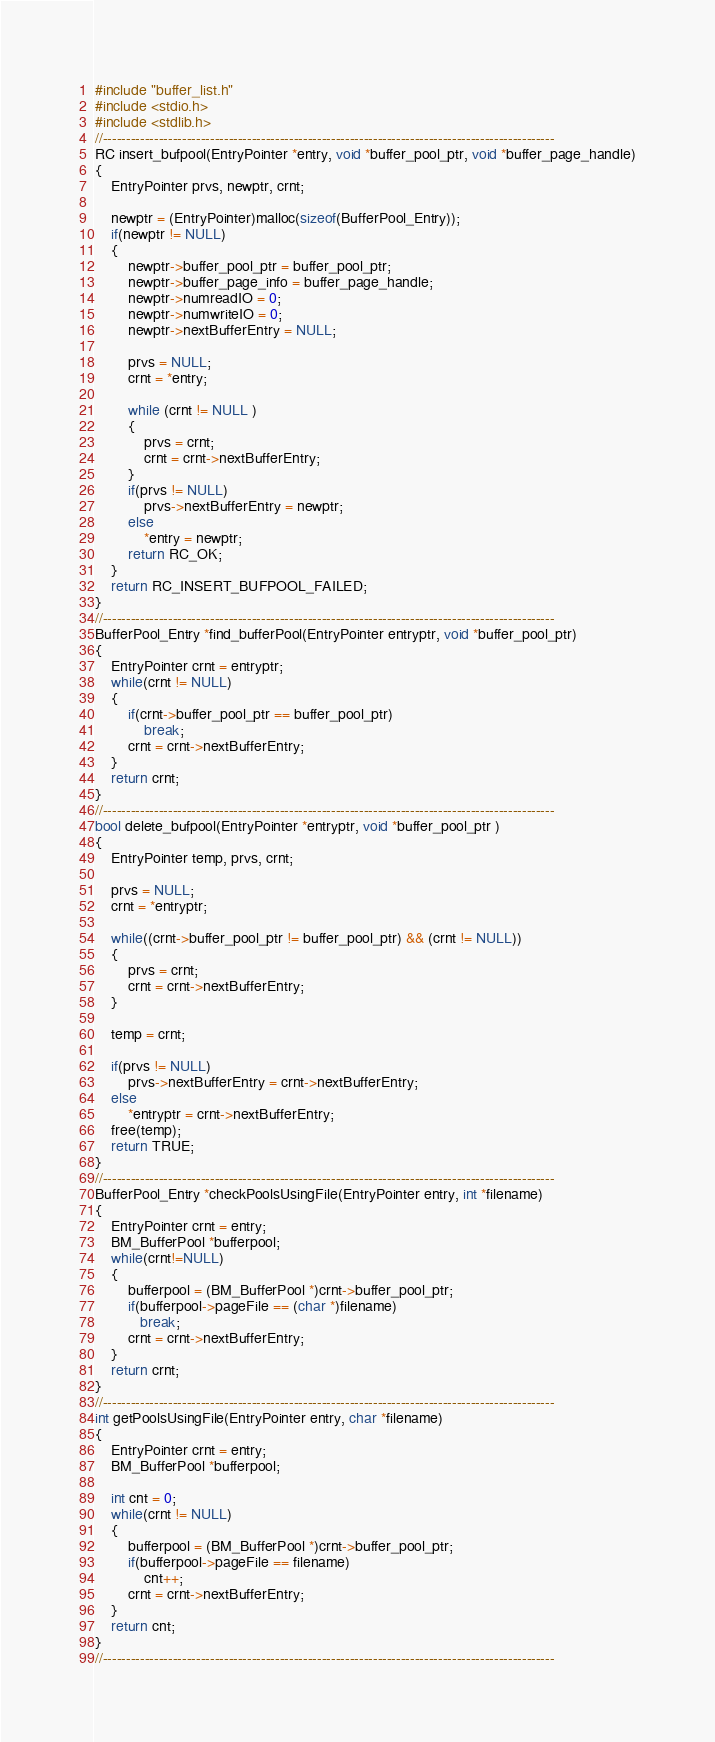Convert code to text. <code><loc_0><loc_0><loc_500><loc_500><_C_>#include "buffer_list.h"
#include <stdio.h>
#include <stdlib.h>
//-------------------------------------------------------------------------------------------------
RC insert_bufpool(EntryPointer *entry, void *buffer_pool_ptr, void *buffer_page_handle)
{    
    EntryPointer prvs, newptr, crnt;

    newptr = (EntryPointer)malloc(sizeof(BufferPool_Entry));
    if(newptr != NULL)
    {
        newptr->buffer_pool_ptr = buffer_pool_ptr;
        newptr->buffer_page_info = buffer_page_handle;
        newptr->numreadIO = 0;
        newptr->numwriteIO = 0;
        newptr->nextBufferEntry = NULL;

        prvs = NULL;
        crnt = *entry;

        while (crnt != NULL )
        {
            prvs = crnt;
            crnt = crnt->nextBufferEntry;
        }
        if(prvs != NULL)
            prvs->nextBufferEntry = newptr;
        else
            *entry = newptr;
        return RC_OK;
    }
    return RC_INSERT_BUFPOOL_FAILED;
}
//-------------------------------------------------------------------------------------------------
BufferPool_Entry *find_bufferPool(EntryPointer entryptr, void *buffer_pool_ptr)
{
    EntryPointer crnt = entryptr;
    while(crnt != NULL)
    {
        if(crnt->buffer_pool_ptr == buffer_pool_ptr)
            break;
        crnt = crnt->nextBufferEntry;
    }
    return crnt;
}
//-------------------------------------------------------------------------------------------------
bool delete_bufpool(EntryPointer *entryptr, void *buffer_pool_ptr )
{
    EntryPointer temp, prvs, crnt;

    prvs = NULL;
    crnt = *entryptr;

    while((crnt->buffer_pool_ptr != buffer_pool_ptr) && (crnt != NULL))
    {
        prvs = crnt;
        crnt = crnt->nextBufferEntry;
    }
    
    temp = crnt;

    if(prvs != NULL)
        prvs->nextBufferEntry = crnt->nextBufferEntry;
    else
        *entryptr = crnt->nextBufferEntry;
    free(temp);
    return TRUE;
}
//-------------------------------------------------------------------------------------------------
BufferPool_Entry *checkPoolsUsingFile(EntryPointer entry, int *filename)
{
    EntryPointer crnt = entry;
    BM_BufferPool *bufferpool;
    while(crnt!=NULL)
    {
        bufferpool = (BM_BufferPool *)crnt->buffer_pool_ptr;
        if(bufferpool->pageFile == (char *)filename)
           break;
        crnt = crnt->nextBufferEntry;
    }
    return crnt;
}
//-------------------------------------------------------------------------------------------------
int getPoolsUsingFile(EntryPointer entry, char *filename)
{
    EntryPointer crnt = entry;
    BM_BufferPool *bufferpool;

    int cnt = 0;
    while(crnt != NULL)
    {
        bufferpool = (BM_BufferPool *)crnt->buffer_pool_ptr;
        if(bufferpool->pageFile == filename)
            cnt++;
        crnt = crnt->nextBufferEntry;
    }
    return cnt;
}
//-------------------------------------------------------------------------------------------------</code> 